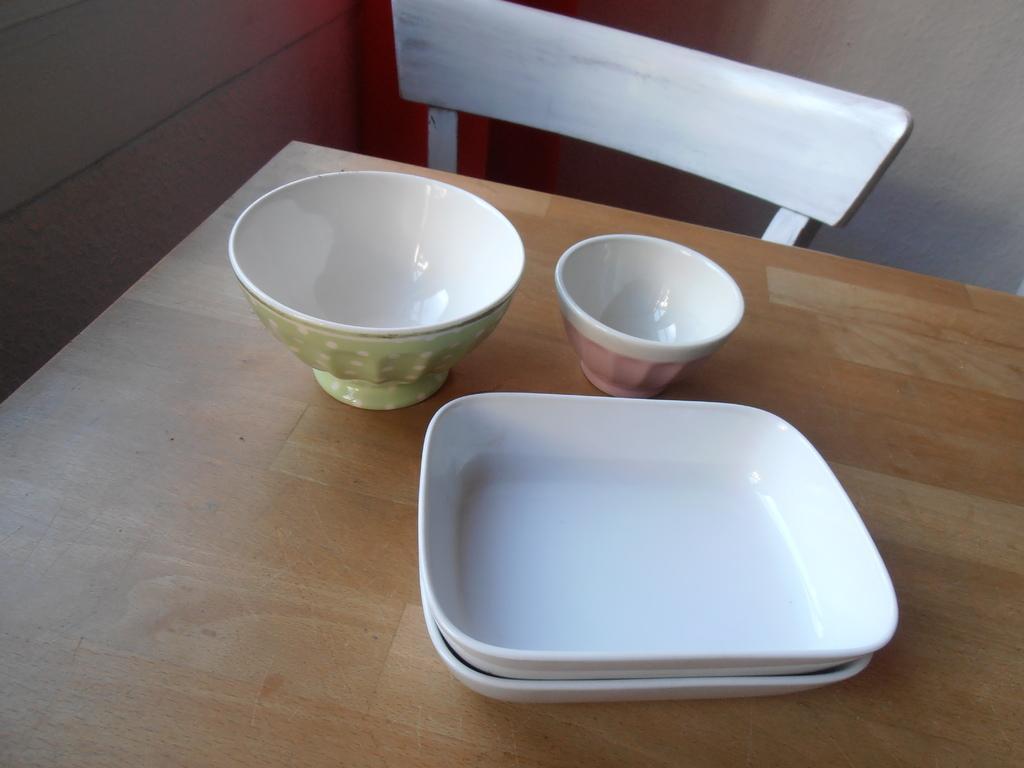How would you summarize this image in a sentence or two? In this image there is a table having plates and bowls on it. Behind the table there is a chair. Background there is a wall. 